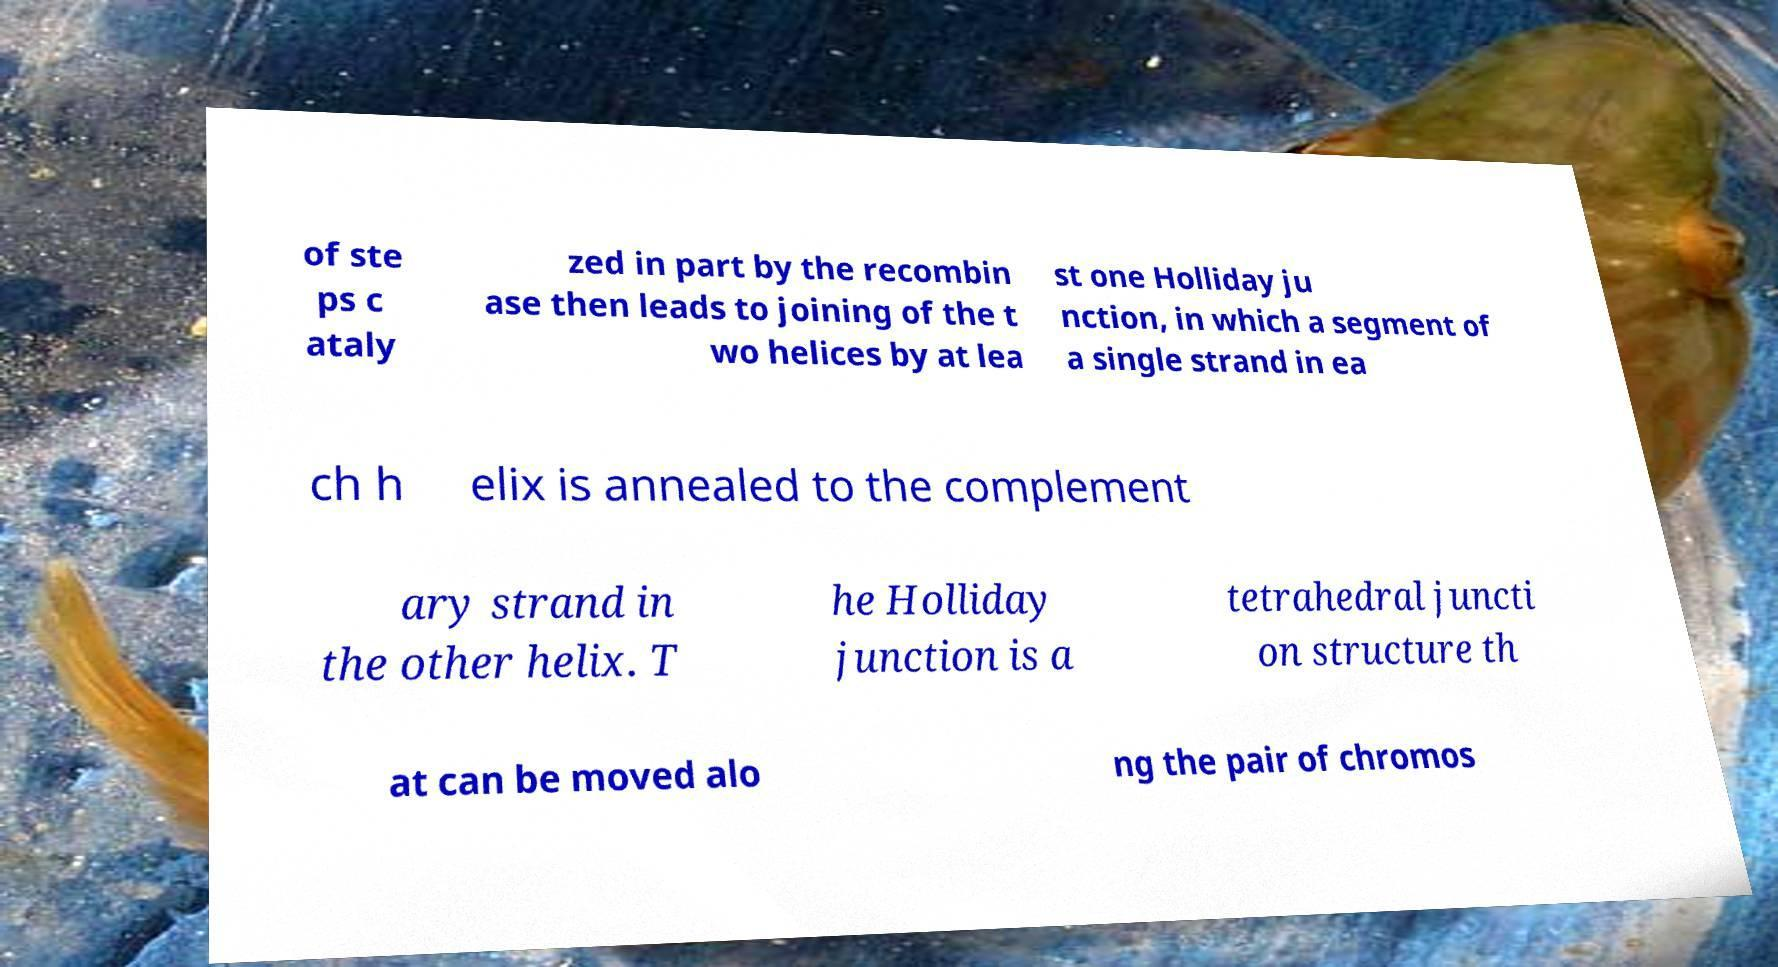Can you read and provide the text displayed in the image?This photo seems to have some interesting text. Can you extract and type it out for me? of ste ps c ataly zed in part by the recombin ase then leads to joining of the t wo helices by at lea st one Holliday ju nction, in which a segment of a single strand in ea ch h elix is annealed to the complement ary strand in the other helix. T he Holliday junction is a tetrahedral juncti on structure th at can be moved alo ng the pair of chromos 